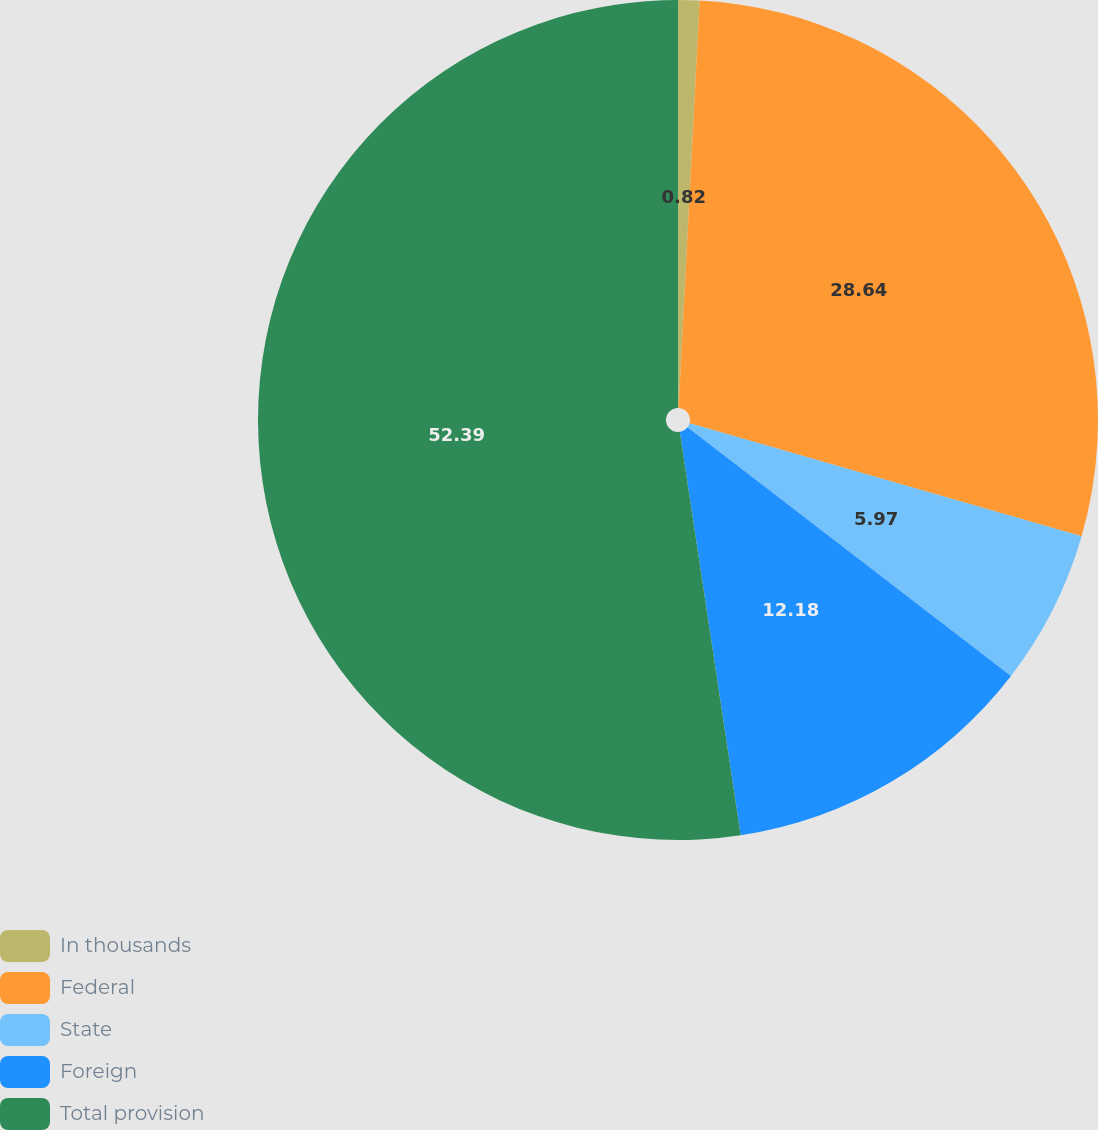Convert chart. <chart><loc_0><loc_0><loc_500><loc_500><pie_chart><fcel>In thousands<fcel>Federal<fcel>State<fcel>Foreign<fcel>Total provision<nl><fcel>0.82%<fcel>28.64%<fcel>5.97%<fcel>12.18%<fcel>52.38%<nl></chart> 